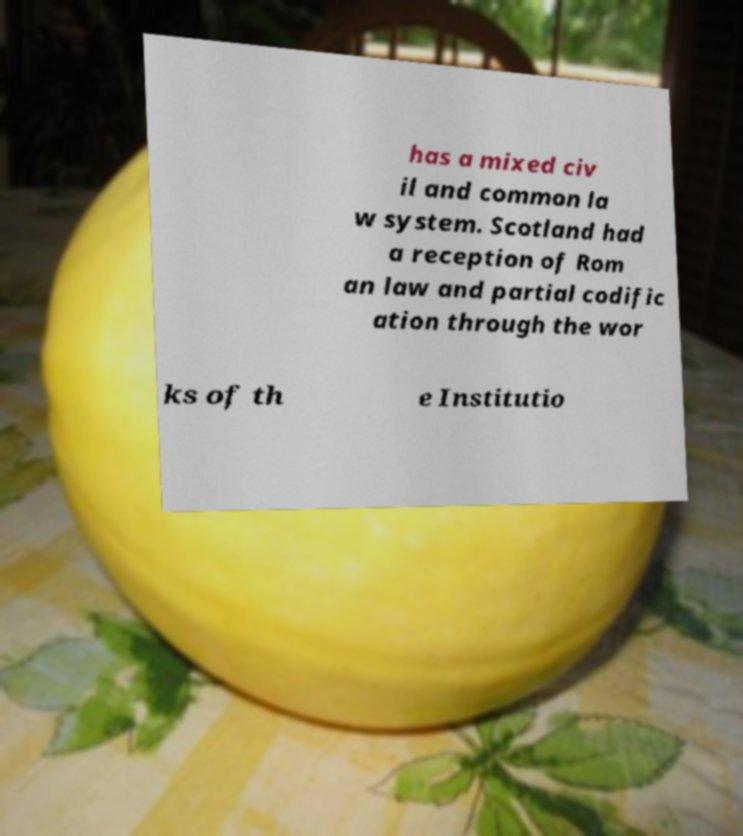What messages or text are displayed in this image? I need them in a readable, typed format. has a mixed civ il and common la w system. Scotland had a reception of Rom an law and partial codific ation through the wor ks of th e Institutio 